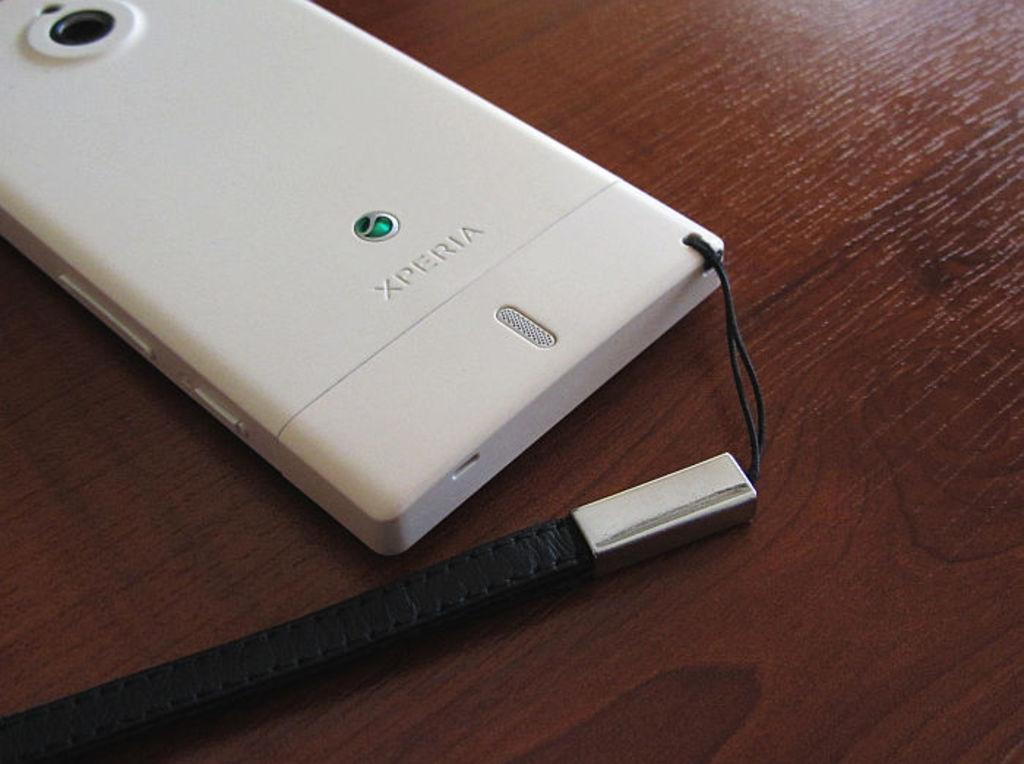<image>
Offer a succinct explanation of the picture presented. an xperia phone laying face down on a dark wood table 